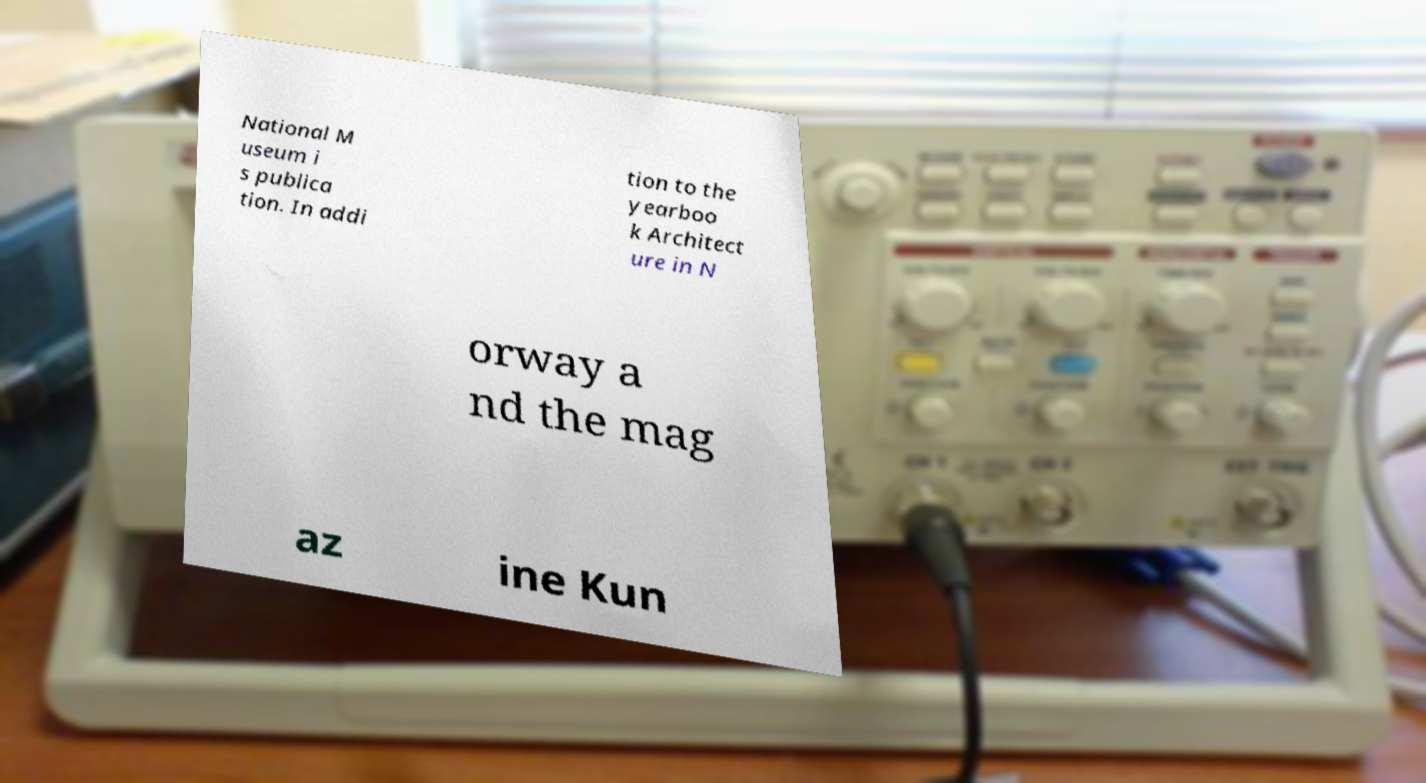There's text embedded in this image that I need extracted. Can you transcribe it verbatim? National M useum i s publica tion. In addi tion to the yearboo k Architect ure in N orway a nd the mag az ine Kun 